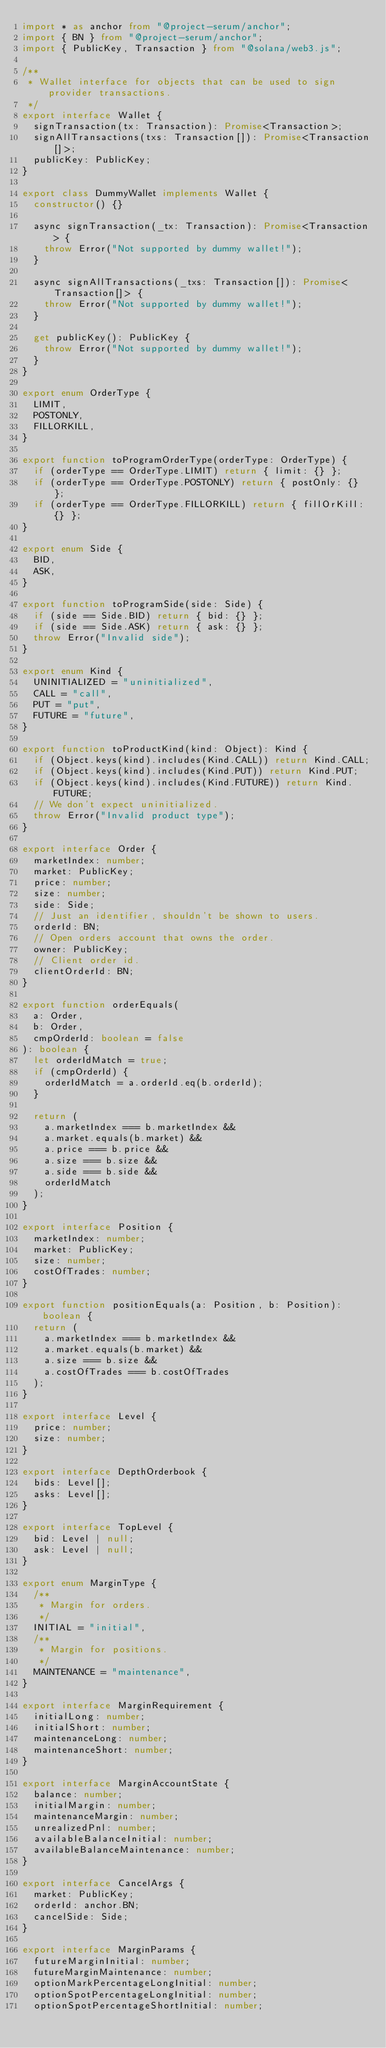Convert code to text. <code><loc_0><loc_0><loc_500><loc_500><_TypeScript_>import * as anchor from "@project-serum/anchor";
import { BN } from "@project-serum/anchor";
import { PublicKey, Transaction } from "@solana/web3.js";

/**
 * Wallet interface for objects that can be used to sign provider transactions.
 */
export interface Wallet {
  signTransaction(tx: Transaction): Promise<Transaction>;
  signAllTransactions(txs: Transaction[]): Promise<Transaction[]>;
  publicKey: PublicKey;
}

export class DummyWallet implements Wallet {
  constructor() {}

  async signTransaction(_tx: Transaction): Promise<Transaction> {
    throw Error("Not supported by dummy wallet!");
  }

  async signAllTransactions(_txs: Transaction[]): Promise<Transaction[]> {
    throw Error("Not supported by dummy wallet!");
  }

  get publicKey(): PublicKey {
    throw Error("Not supported by dummy wallet!");
  }
}

export enum OrderType {
  LIMIT,
  POSTONLY,
  FILLORKILL,
}

export function toProgramOrderType(orderType: OrderType) {
  if (orderType == OrderType.LIMIT) return { limit: {} };
  if (orderType == OrderType.POSTONLY) return { postOnly: {} };
  if (orderType == OrderType.FILLORKILL) return { fillOrKill: {} };
}

export enum Side {
  BID,
  ASK,
}

export function toProgramSide(side: Side) {
  if (side == Side.BID) return { bid: {} };
  if (side == Side.ASK) return { ask: {} };
  throw Error("Invalid side");
}

export enum Kind {
  UNINITIALIZED = "uninitialized",
  CALL = "call",
  PUT = "put",
  FUTURE = "future",
}

export function toProductKind(kind: Object): Kind {
  if (Object.keys(kind).includes(Kind.CALL)) return Kind.CALL;
  if (Object.keys(kind).includes(Kind.PUT)) return Kind.PUT;
  if (Object.keys(kind).includes(Kind.FUTURE)) return Kind.FUTURE;
  // We don't expect uninitialized.
  throw Error("Invalid product type");
}

export interface Order {
  marketIndex: number;
  market: PublicKey;
  price: number;
  size: number;
  side: Side;
  // Just an identifier, shouldn't be shown to users.
  orderId: BN;
  // Open orders account that owns the order.
  owner: PublicKey;
  // Client order id.
  clientOrderId: BN;
}

export function orderEquals(
  a: Order,
  b: Order,
  cmpOrderId: boolean = false
): boolean {
  let orderIdMatch = true;
  if (cmpOrderId) {
    orderIdMatch = a.orderId.eq(b.orderId);
  }

  return (
    a.marketIndex === b.marketIndex &&
    a.market.equals(b.market) &&
    a.price === b.price &&
    a.size === b.size &&
    a.side === b.side &&
    orderIdMatch
  );
}

export interface Position {
  marketIndex: number;
  market: PublicKey;
  size: number;
  costOfTrades: number;
}

export function positionEquals(a: Position, b: Position): boolean {
  return (
    a.marketIndex === b.marketIndex &&
    a.market.equals(b.market) &&
    a.size === b.size &&
    a.costOfTrades === b.costOfTrades
  );
}

export interface Level {
  price: number;
  size: number;
}

export interface DepthOrderbook {
  bids: Level[];
  asks: Level[];
}

export interface TopLevel {
  bid: Level | null;
  ask: Level | null;
}

export enum MarginType {
  /**
   * Margin for orders.
   */
  INITIAL = "initial",
  /**
   * Margin for positions.
   */
  MAINTENANCE = "maintenance",
}

export interface MarginRequirement {
  initialLong: number;
  initialShort: number;
  maintenanceLong: number;
  maintenanceShort: number;
}

export interface MarginAccountState {
  balance: number;
  initialMargin: number;
  maintenanceMargin: number;
  unrealizedPnl: number;
  availableBalanceInitial: number;
  availableBalanceMaintenance: number;
}

export interface CancelArgs {
  market: PublicKey;
  orderId: anchor.BN;
  cancelSide: Side;
}

export interface MarginParams {
  futureMarginInitial: number;
  futureMarginMaintenance: number;
  optionMarkPercentageLongInitial: number;
  optionSpotPercentageLongInitial: number;
  optionSpotPercentageShortInitial: number;</code> 